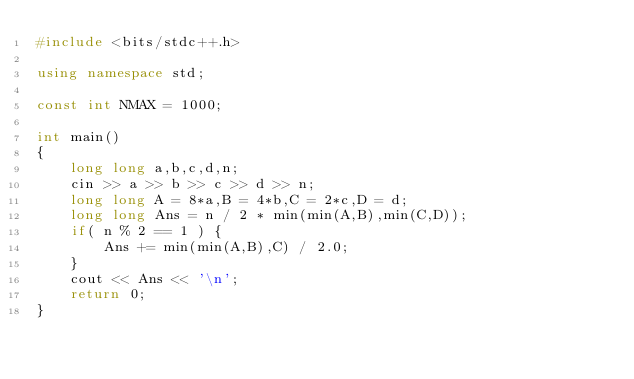<code> <loc_0><loc_0><loc_500><loc_500><_C++_>#include <bits/stdc++.h>

using namespace std;

const int NMAX = 1000;

int main()
{
    long long a,b,c,d,n;
    cin >> a >> b >> c >> d >> n;
    long long A = 8*a,B = 4*b,C = 2*c,D = d;
    long long Ans = n / 2 * min(min(A,B),min(C,D));
    if( n % 2 == 1 ) {
        Ans += min(min(A,B),C) / 2.0;
    }
    cout << Ans << '\n';
    return 0;
}
</code> 